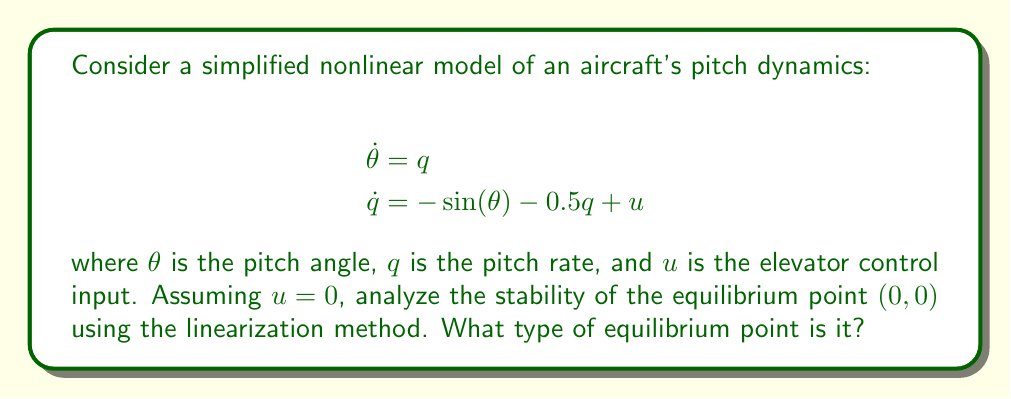Can you solve this math problem? To analyze the stability of the equilibrium point $(0, 0)$, we'll follow these steps:

1. Verify the equilibrium point:
   At $(0, 0)$, we have:
   $$\dot{\theta} = 0 = q = 0$$
   $$\dot{q} = 0 = -\sin(0) - 0.5(0) + 0 = 0$$
   So $(0, 0)$ is indeed an equilibrium point.

2. Linearize the system around $(0, 0)$:
   The Jacobian matrix $J$ at $(\theta, q)$ is:
   $$J = \begin{bmatrix}
   \frac{\partial \dot{\theta}}{\partial \theta} & \frac{\partial \dot{\theta}}{\partial q} \\
   \frac{\partial \dot{q}}{\partial \theta} & \frac{\partial \dot{q}}{\partial q}
   \end{bmatrix} = \begin{bmatrix}
   0 & 1 \\
   -\cos(\theta) & -0.5
   \end{bmatrix}$$

   At $(0, 0)$, the linearized system is:
   $$J_{(0,0)} = \begin{bmatrix}
   0 & 1 \\
   -1 & -0.5
   \end{bmatrix}$$

3. Find the eigenvalues of $J_{(0,0)}$:
   The characteristic equation is:
   $$\det(J_{(0,0)} - \lambda I) = \lambda^2 + 0.5\lambda + 1 = 0$$

   Solving this equation:
   $$\lambda = \frac{-0.5 \pm \sqrt{0.25 - 4}}{2} = -0.25 \pm 0.9682i$$

4. Analyze the eigenvalues:
   The real part of both eigenvalues is negative (-0.25), and there's a non-zero imaginary part.

5. Determine the type of equilibrium:
   Negative real parts indicate asymptotic stability, while the imaginary parts suggest oscillatory behavior.
Answer: Stable focus 